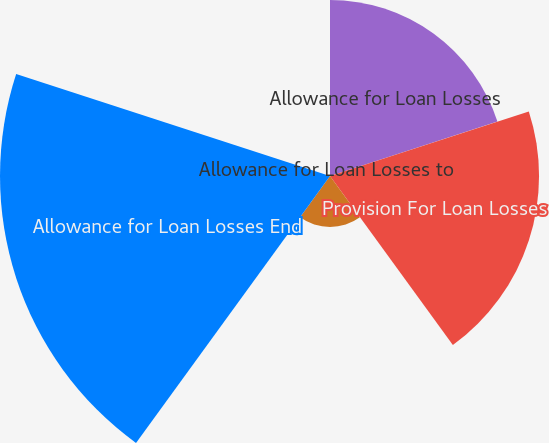Convert chart. <chart><loc_0><loc_0><loc_500><loc_500><pie_chart><fcel>Allowance for Loan Losses<fcel>Provision For Loan Losses<fcel>Net Charge-Offs<fcel>Allowance for Loan Losses End<fcel>Allowance for Loan Losses to<nl><fcel>22.98%<fcel>27.29%<fcel>6.65%<fcel>43.08%<fcel>0.0%<nl></chart> 